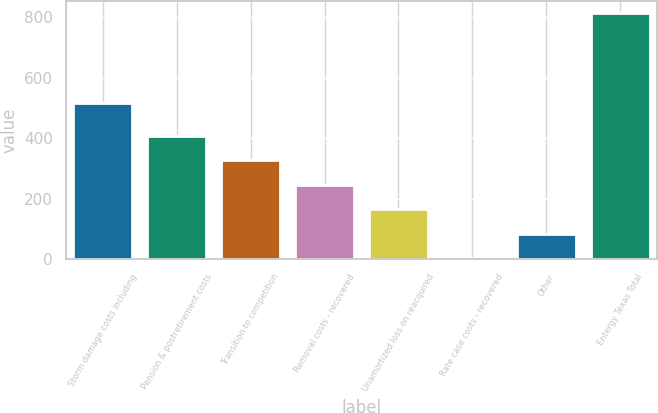Convert chart to OTSL. <chart><loc_0><loc_0><loc_500><loc_500><bar_chart><fcel>Storm damage costs including<fcel>Pension & postretirement costs<fcel>Transition to competition<fcel>Removal costs - recovered<fcel>Unamortized loss on reacquired<fcel>Rate case costs - recovered<fcel>Other<fcel>Entergy Texas Total<nl><fcel>516.2<fcel>408.35<fcel>327.44<fcel>246.53<fcel>165.62<fcel>3.8<fcel>84.71<fcel>812.9<nl></chart> 